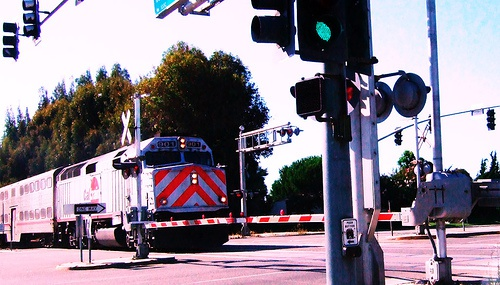Describe the objects in this image and their specific colors. I can see train in white, lavender, black, blue, and pink tones, traffic light in white, black, and turquoise tones, traffic light in white, black, navy, lavender, and darkblue tones, traffic light in white, black, navy, and gray tones, and traffic light in white, black, and purple tones in this image. 